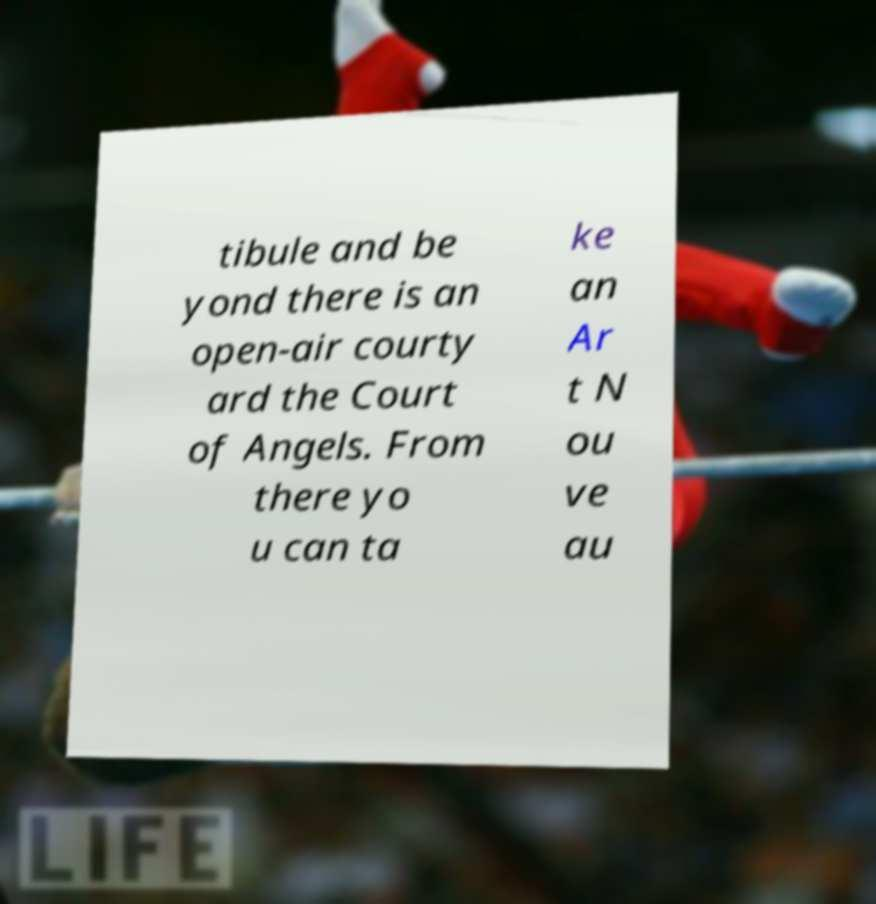Please read and relay the text visible in this image. What does it say? tibule and be yond there is an open-air courty ard the Court of Angels. From there yo u can ta ke an Ar t N ou ve au 